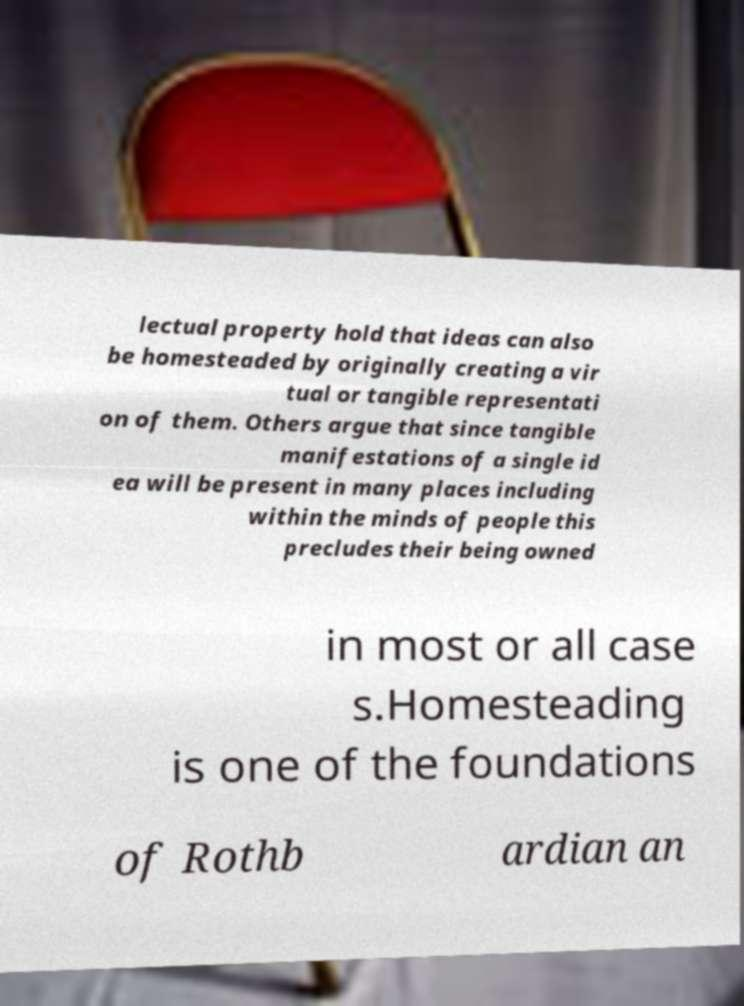Could you extract and type out the text from this image? lectual property hold that ideas can also be homesteaded by originally creating a vir tual or tangible representati on of them. Others argue that since tangible manifestations of a single id ea will be present in many places including within the minds of people this precludes their being owned in most or all case s.Homesteading is one of the foundations of Rothb ardian an 